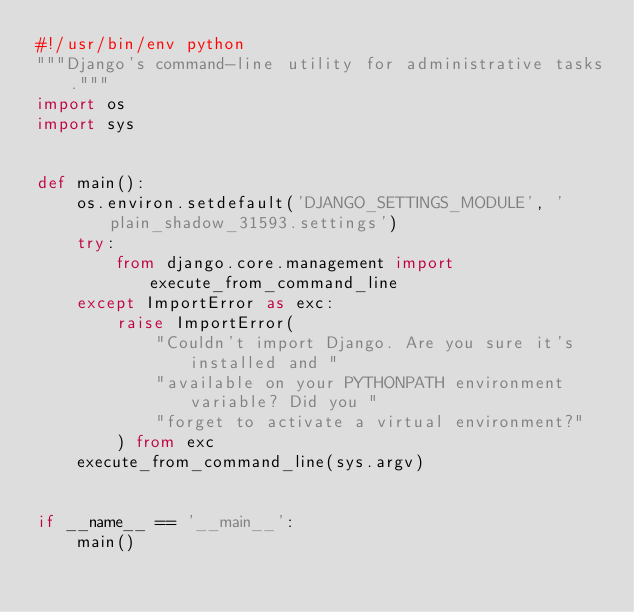<code> <loc_0><loc_0><loc_500><loc_500><_Python_>#!/usr/bin/env python
"""Django's command-line utility for administrative tasks."""
import os
import sys


def main():
    os.environ.setdefault('DJANGO_SETTINGS_MODULE', 'plain_shadow_31593.settings')
    try:
        from django.core.management import execute_from_command_line
    except ImportError as exc:
        raise ImportError(
            "Couldn't import Django. Are you sure it's installed and "
            "available on your PYTHONPATH environment variable? Did you "
            "forget to activate a virtual environment?"
        ) from exc
    execute_from_command_line(sys.argv)


if __name__ == '__main__':
    main()
</code> 